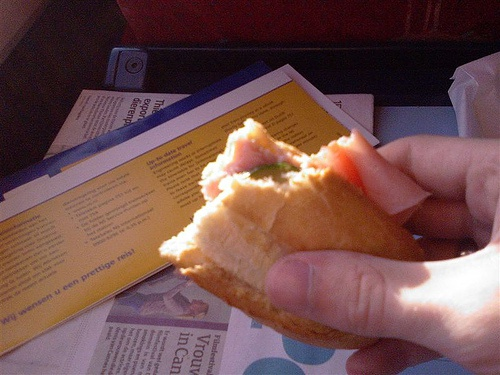Describe the objects in this image and their specific colors. I can see sandwich in maroon, brown, and ivory tones and people in maroon, brown, and white tones in this image. 